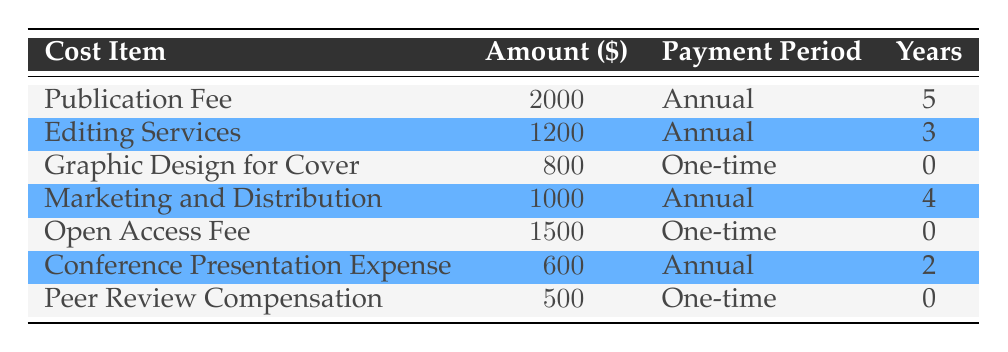What is the cost item with the highest amount? By examining the "Amount" column, we can see that the "Publication Fee" is listed at \$2000, which is the highest among all cost items in the table.
Answer: Publication Fee How many cost items are associated with a one-time payment? Looking at the "Payment Period" column, we find three cost items labeled as "One-time": Graphic Design for Cover, Open Access Fee, and Peer Review Compensation, making a total of 3 items.
Answer: 3 What is the total annual cost for all expenses that have an annual payment period? We sum the amounts for the cost items that are paid annually, which are: Publication Fee (\$2000) + Editing Services (\$1200) + Marketing and Distribution (\$1000) + Conference Presentation Expense (\$600). This totals to \$2000 + \$1200 + \$1000 + \$600 = \$4800.
Answer: 4800 Do any cost items incur a fee of less than \$1000? Observing the "Amount" column, we see that both the Conference Presentation Expense (\$600) and the Peer Review Compensation (\$500) are less than \$1000. Therefore, the answer is yes.
Answer: Yes What is the average cost of the items that require annual payments? To find the average, we first sum the amounts for annual payments: Publication Fee (\$2000) + Editing Services (\$1200) + Marketing and Distribution (\$1000) + Conference Presentation Expense (\$600) = \$4800, and then divide by the number of items (4). The average is \$4800 / 4 = \$1200.
Answer: 1200 Is the total amount for the cost items with a duration of more than 3 years greater than \$5000? The cost items with more than 3 years are the Publication Fee (5 years) and Marketing and Distribution (4 years). Their totals are \$2000 and \$1000, giving us \$2000 + \$1000 = \$3000, which is less than \$5000.
Answer: No Which cost item has the shortest payment duration? The "Peer Review Compensation," "Graphic Design for Cover," and "Open Access Fee" all list a duration of 0 years. Since they are tied, we can state that they share this characteristic.
Answer: Peer Review Compensation, Graphic Design for Cover, Open Access Fee What is the total amount spent on Editing Services across all years? Since Editing Services have an annual cost of \$1200 and are spread over 3 years, the total amount spent can be calculated as \$1200 multiplied by 3, which equals \$3600.
Answer: 3600 